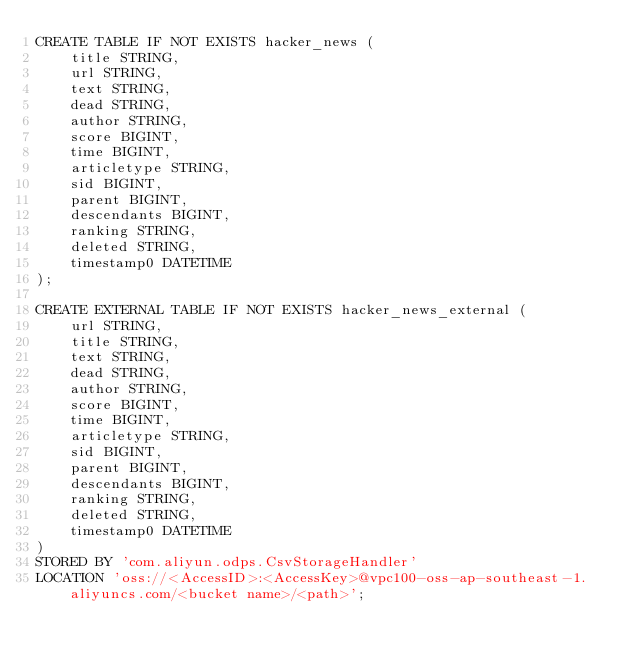Convert code to text. <code><loc_0><loc_0><loc_500><loc_500><_SQL_>CREATE TABLE IF NOT EXISTS hacker_news (
    title STRING,
    url STRING,
    text STRING,
    dead STRING,
    author STRING,
    score BIGINT,
    time BIGINT,
    articletype STRING,
    sid BIGINT,
    parent BIGINT,
    descendants BIGINT,
    ranking STRING,
    deleted STRING,
    timestamp0 DATETIME
);

CREATE EXTERNAL TABLE IF NOT EXISTS hacker_news_external (
    url STRING,
    title STRING,
    text STRING,
    dead STRING,
    author STRING,
    score BIGINT,
    time BIGINT,
    articletype STRING,
    sid BIGINT,
    parent BIGINT,
    descendants BIGINT,
    ranking STRING,
    deleted STRING,
    timestamp0 DATETIME
)
STORED BY 'com.aliyun.odps.CsvStorageHandler'
LOCATION 'oss://<AccessID>:<AccessKey>@vpc100-oss-ap-southeast-1.aliyuncs.com/<bucket name>/<path>';</code> 